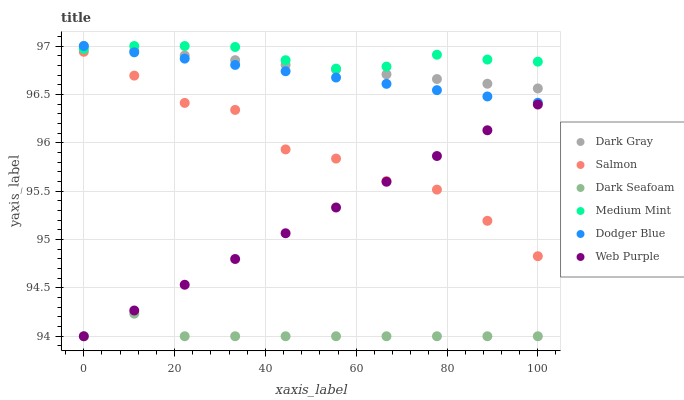Does Dark Seafoam have the minimum area under the curve?
Answer yes or no. Yes. Does Medium Mint have the maximum area under the curve?
Answer yes or no. Yes. Does Salmon have the minimum area under the curve?
Answer yes or no. No. Does Salmon have the maximum area under the curve?
Answer yes or no. No. Is Dodger Blue the smoothest?
Answer yes or no. Yes. Is Salmon the roughest?
Answer yes or no. Yes. Is Web Purple the smoothest?
Answer yes or no. No. Is Web Purple the roughest?
Answer yes or no. No. Does Web Purple have the lowest value?
Answer yes or no. Yes. Does Salmon have the lowest value?
Answer yes or no. No. Does Dodger Blue have the highest value?
Answer yes or no. Yes. Does Salmon have the highest value?
Answer yes or no. No. Is Web Purple less than Dark Gray?
Answer yes or no. Yes. Is Dodger Blue greater than Salmon?
Answer yes or no. Yes. Does Medium Mint intersect Dodger Blue?
Answer yes or no. Yes. Is Medium Mint less than Dodger Blue?
Answer yes or no. No. Is Medium Mint greater than Dodger Blue?
Answer yes or no. No. Does Web Purple intersect Dark Gray?
Answer yes or no. No. 